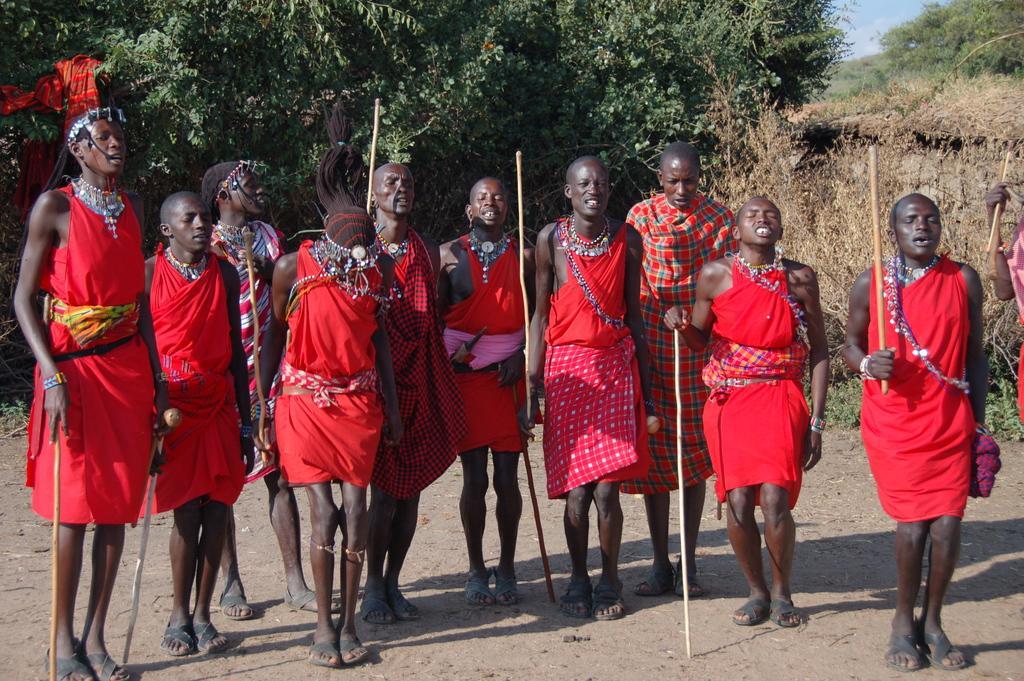Describe this image in one or two sentences. In this image I can see a group of people standing and holding a stick in their hands. In the background, I can see the trees and clouds in the sky. 